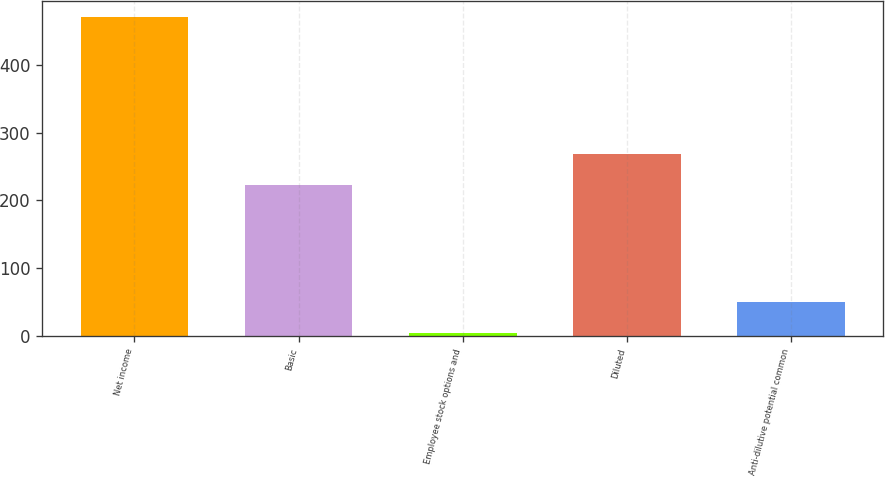<chart> <loc_0><loc_0><loc_500><loc_500><bar_chart><fcel>Net income<fcel>Basic<fcel>Employee stock options and<fcel>Diluted<fcel>Anti-dilutive potential common<nl><fcel>470<fcel>222<fcel>4<fcel>268.6<fcel>50.6<nl></chart> 